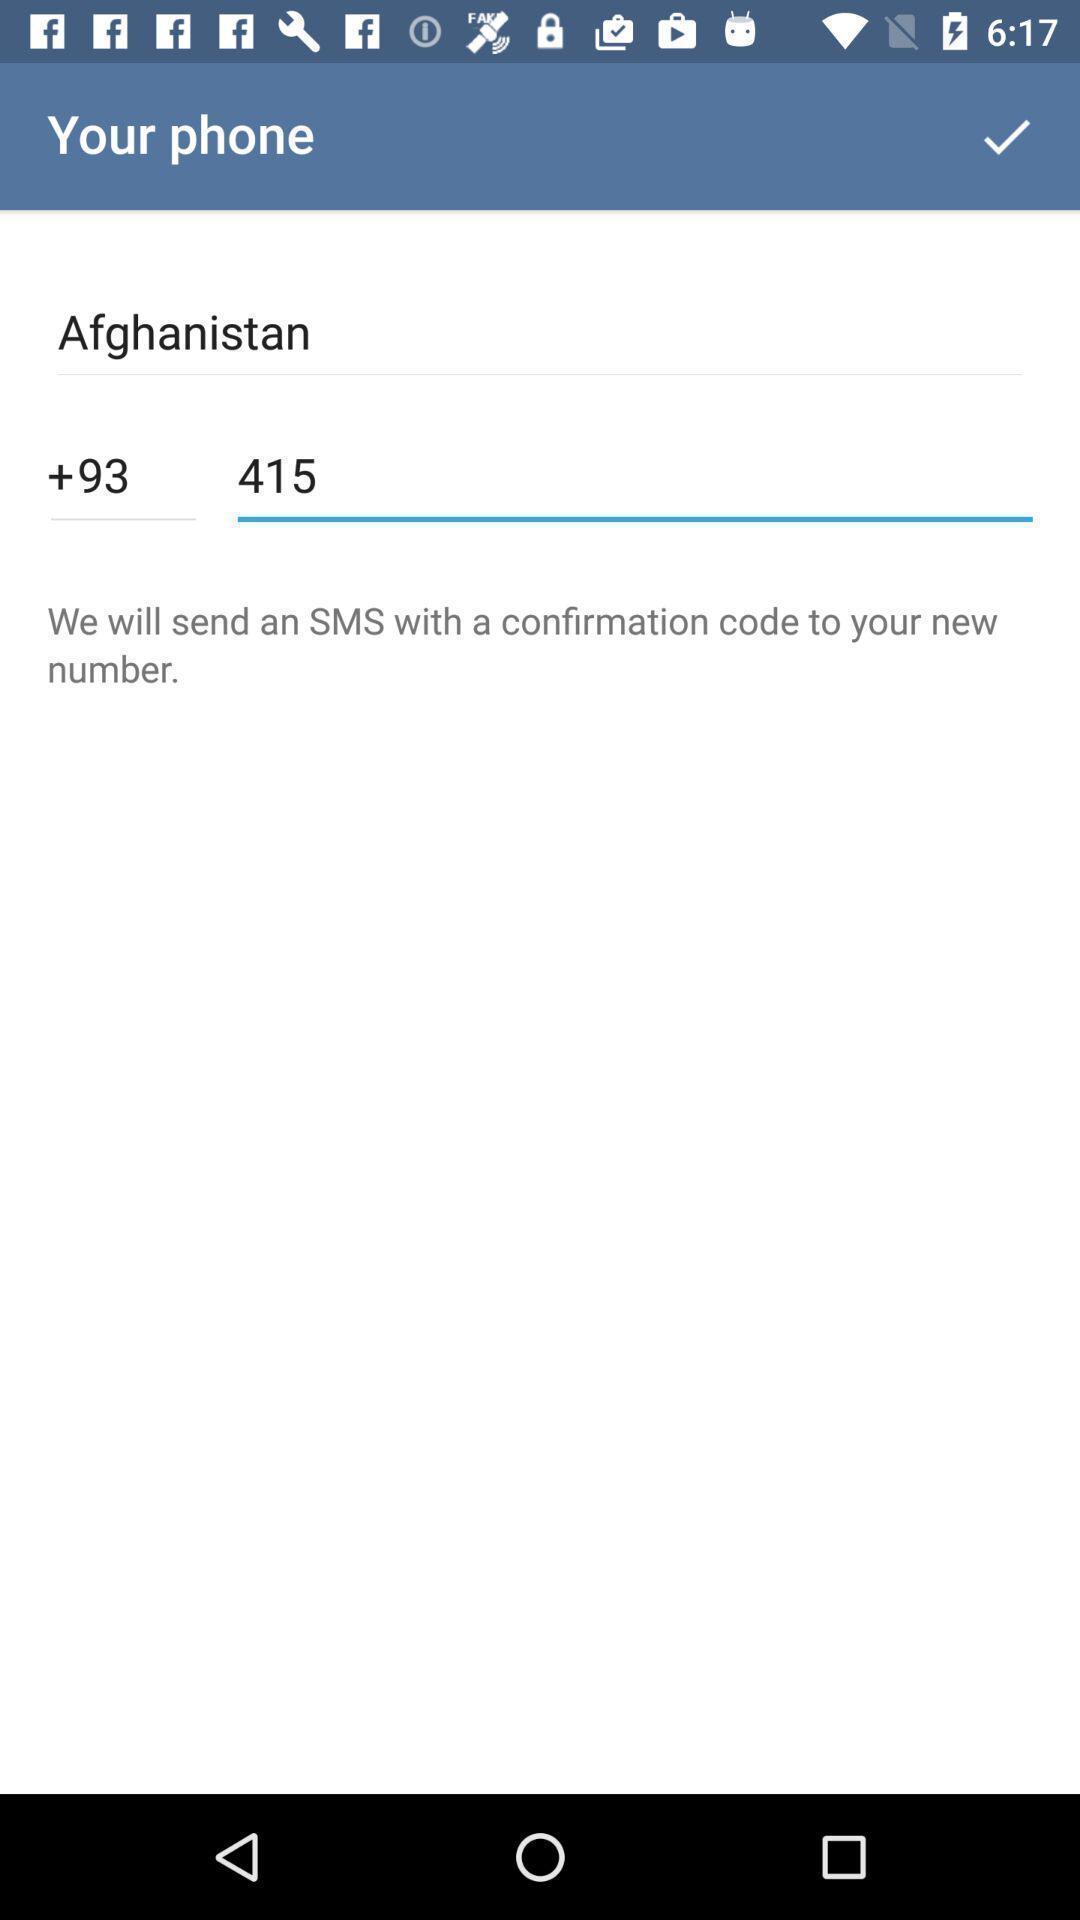Provide a detailed account of this screenshot. Page displaying to enter the number. 